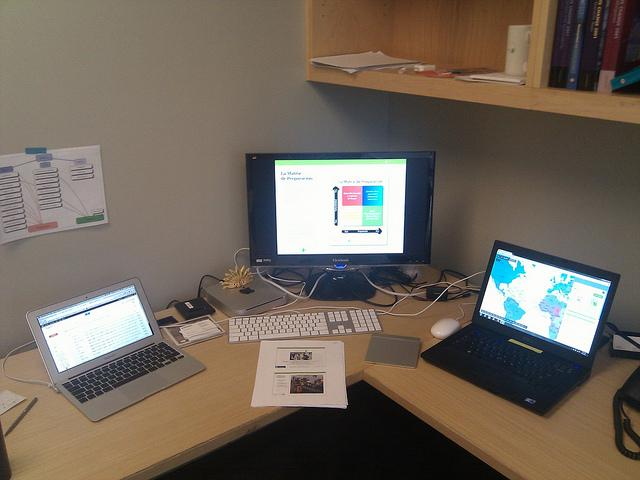On which computer could one find directions the fastest? right laptop 